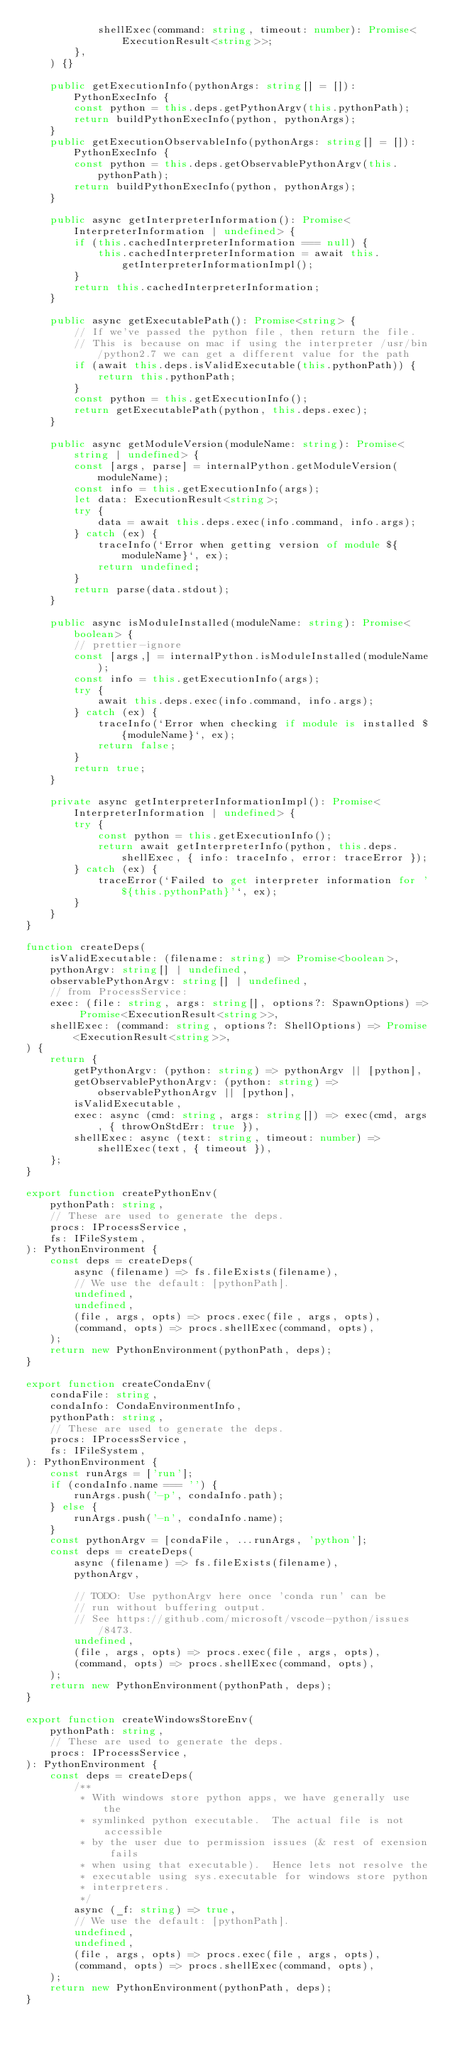<code> <loc_0><loc_0><loc_500><loc_500><_TypeScript_>            shellExec(command: string, timeout: number): Promise<ExecutionResult<string>>;
        },
    ) {}

    public getExecutionInfo(pythonArgs: string[] = []): PythonExecInfo {
        const python = this.deps.getPythonArgv(this.pythonPath);
        return buildPythonExecInfo(python, pythonArgs);
    }
    public getExecutionObservableInfo(pythonArgs: string[] = []): PythonExecInfo {
        const python = this.deps.getObservablePythonArgv(this.pythonPath);
        return buildPythonExecInfo(python, pythonArgs);
    }

    public async getInterpreterInformation(): Promise<InterpreterInformation | undefined> {
        if (this.cachedInterpreterInformation === null) {
            this.cachedInterpreterInformation = await this.getInterpreterInformationImpl();
        }
        return this.cachedInterpreterInformation;
    }

    public async getExecutablePath(): Promise<string> {
        // If we've passed the python file, then return the file.
        // This is because on mac if using the interpreter /usr/bin/python2.7 we can get a different value for the path
        if (await this.deps.isValidExecutable(this.pythonPath)) {
            return this.pythonPath;
        }
        const python = this.getExecutionInfo();
        return getExecutablePath(python, this.deps.exec);
    }

    public async getModuleVersion(moduleName: string): Promise<string | undefined> {
        const [args, parse] = internalPython.getModuleVersion(moduleName);
        const info = this.getExecutionInfo(args);
        let data: ExecutionResult<string>;
        try {
            data = await this.deps.exec(info.command, info.args);
        } catch (ex) {
            traceInfo(`Error when getting version of module ${moduleName}`, ex);
            return undefined;
        }
        return parse(data.stdout);
    }

    public async isModuleInstalled(moduleName: string): Promise<boolean> {
        // prettier-ignore
        const [args,] = internalPython.isModuleInstalled(moduleName);
        const info = this.getExecutionInfo(args);
        try {
            await this.deps.exec(info.command, info.args);
        } catch (ex) {
            traceInfo(`Error when checking if module is installed ${moduleName}`, ex);
            return false;
        }
        return true;
    }

    private async getInterpreterInformationImpl(): Promise<InterpreterInformation | undefined> {
        try {
            const python = this.getExecutionInfo();
            return await getInterpreterInfo(python, this.deps.shellExec, { info: traceInfo, error: traceError });
        } catch (ex) {
            traceError(`Failed to get interpreter information for '${this.pythonPath}'`, ex);
        }
    }
}

function createDeps(
    isValidExecutable: (filename: string) => Promise<boolean>,
    pythonArgv: string[] | undefined,
    observablePythonArgv: string[] | undefined,
    // from ProcessService:
    exec: (file: string, args: string[], options?: SpawnOptions) => Promise<ExecutionResult<string>>,
    shellExec: (command: string, options?: ShellOptions) => Promise<ExecutionResult<string>>,
) {
    return {
        getPythonArgv: (python: string) => pythonArgv || [python],
        getObservablePythonArgv: (python: string) => observablePythonArgv || [python],
        isValidExecutable,
        exec: async (cmd: string, args: string[]) => exec(cmd, args, { throwOnStdErr: true }),
        shellExec: async (text: string, timeout: number) => shellExec(text, { timeout }),
    };
}

export function createPythonEnv(
    pythonPath: string,
    // These are used to generate the deps.
    procs: IProcessService,
    fs: IFileSystem,
): PythonEnvironment {
    const deps = createDeps(
        async (filename) => fs.fileExists(filename),
        // We use the default: [pythonPath].
        undefined,
        undefined,
        (file, args, opts) => procs.exec(file, args, opts),
        (command, opts) => procs.shellExec(command, opts),
    );
    return new PythonEnvironment(pythonPath, deps);
}

export function createCondaEnv(
    condaFile: string,
    condaInfo: CondaEnvironmentInfo,
    pythonPath: string,
    // These are used to generate the deps.
    procs: IProcessService,
    fs: IFileSystem,
): PythonEnvironment {
    const runArgs = ['run'];
    if (condaInfo.name === '') {
        runArgs.push('-p', condaInfo.path);
    } else {
        runArgs.push('-n', condaInfo.name);
    }
    const pythonArgv = [condaFile, ...runArgs, 'python'];
    const deps = createDeps(
        async (filename) => fs.fileExists(filename),
        pythonArgv,

        // TODO: Use pythonArgv here once 'conda run' can be
        // run without buffering output.
        // See https://github.com/microsoft/vscode-python/issues/8473.
        undefined,
        (file, args, opts) => procs.exec(file, args, opts),
        (command, opts) => procs.shellExec(command, opts),
    );
    return new PythonEnvironment(pythonPath, deps);
}

export function createWindowsStoreEnv(
    pythonPath: string,
    // These are used to generate the deps.
    procs: IProcessService,
): PythonEnvironment {
    const deps = createDeps(
        /**
         * With windows store python apps, we have generally use the
         * symlinked python executable.  The actual file is not accessible
         * by the user due to permission issues (& rest of exension fails
         * when using that executable).  Hence lets not resolve the
         * executable using sys.executable for windows store python
         * interpreters.
         */
        async (_f: string) => true,
        // We use the default: [pythonPath].
        undefined,
        undefined,
        (file, args, opts) => procs.exec(file, args, opts),
        (command, opts) => procs.shellExec(command, opts),
    );
    return new PythonEnvironment(pythonPath, deps);
}
</code> 